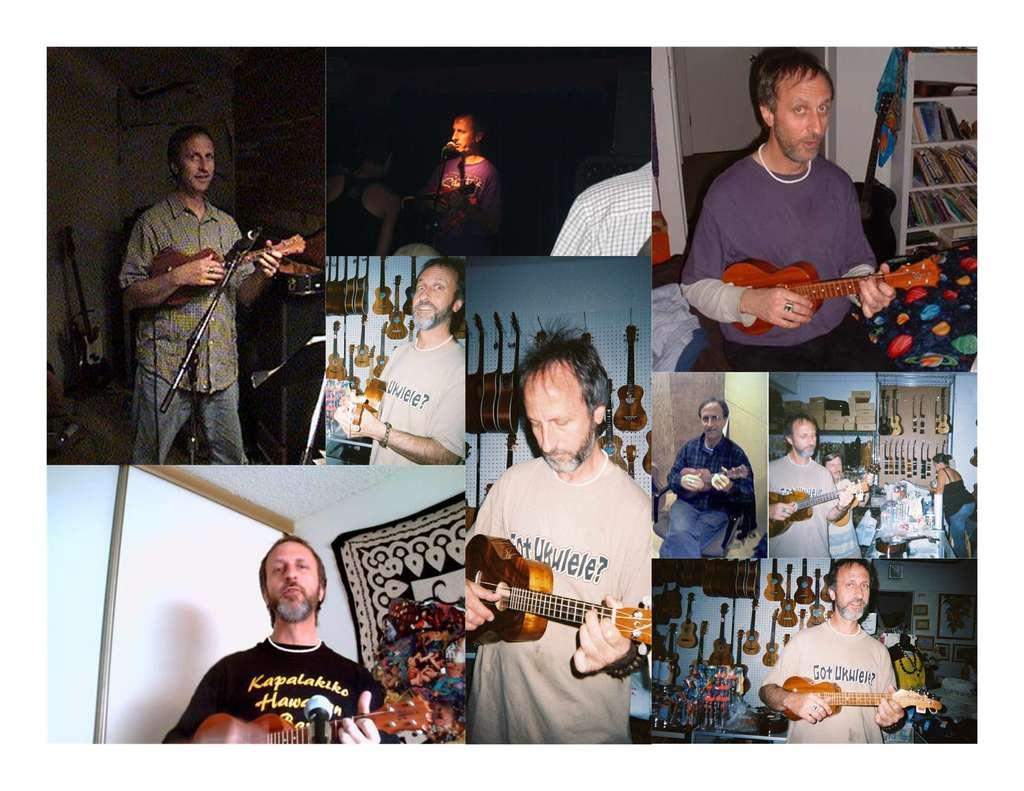What is the main subject of the image? There is a man in the image. What is the man doing in the image? The man is standing in the image. What object is the man holding in the image? The man is holding a guitar in his hand. How many cushions are visible in the image? There are no cushions present in the image. Are the man's brothers also visible in the image? There is no mention of the man having brothers or any other people in the image. 